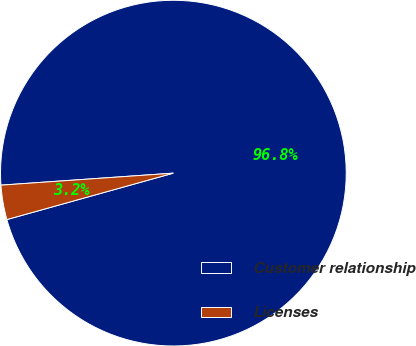Convert chart to OTSL. <chart><loc_0><loc_0><loc_500><loc_500><pie_chart><fcel>Customer relationship<fcel>Licenses<nl><fcel>96.78%<fcel>3.22%<nl></chart> 